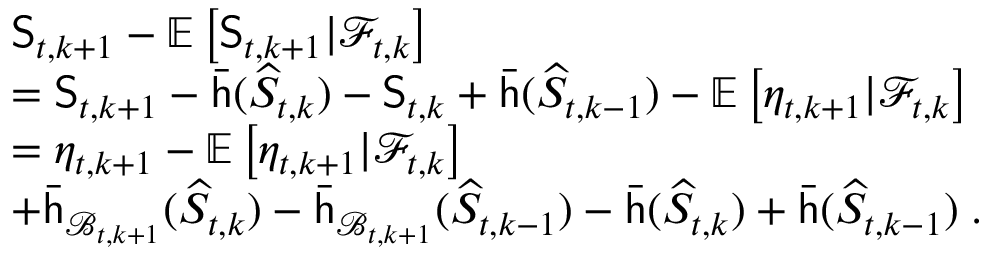Convert formula to latex. <formula><loc_0><loc_0><loc_500><loc_500>\begin{array} { r l } & { S _ { t , k + 1 } - \mathbb { E } \left [ S _ { t , k + 1 } | \mathcal { F } _ { t , k } \right ] } \\ & { = S _ { t , k + 1 } - \bar { h } ( \widehat { S } _ { t , k } ) - S _ { t , k } + \bar { h } ( \widehat { S } _ { t , k - 1 } ) - \mathbb { E } \left [ \eta _ { t , k + 1 } | \mathcal { F } _ { t , k } \right ] } \\ & { = \eta _ { t , k + 1 } - \mathbb { E } \left [ \eta _ { t , k + 1 } | \mathcal { F } _ { t , k } \right ] } \\ & { + \bar { h } _ { \mathcal { B } _ { t , k + 1 } } ( \widehat { S } _ { t , k } ) - \bar { h } _ { \mathcal { B } _ { t , k + 1 } } ( \widehat { S } _ { t , k - 1 } ) - \bar { h } ( \widehat { S } _ { t , k } ) + \bar { h } ( \widehat { S } _ { t , k - 1 } ) \, . } \end{array}</formula> 